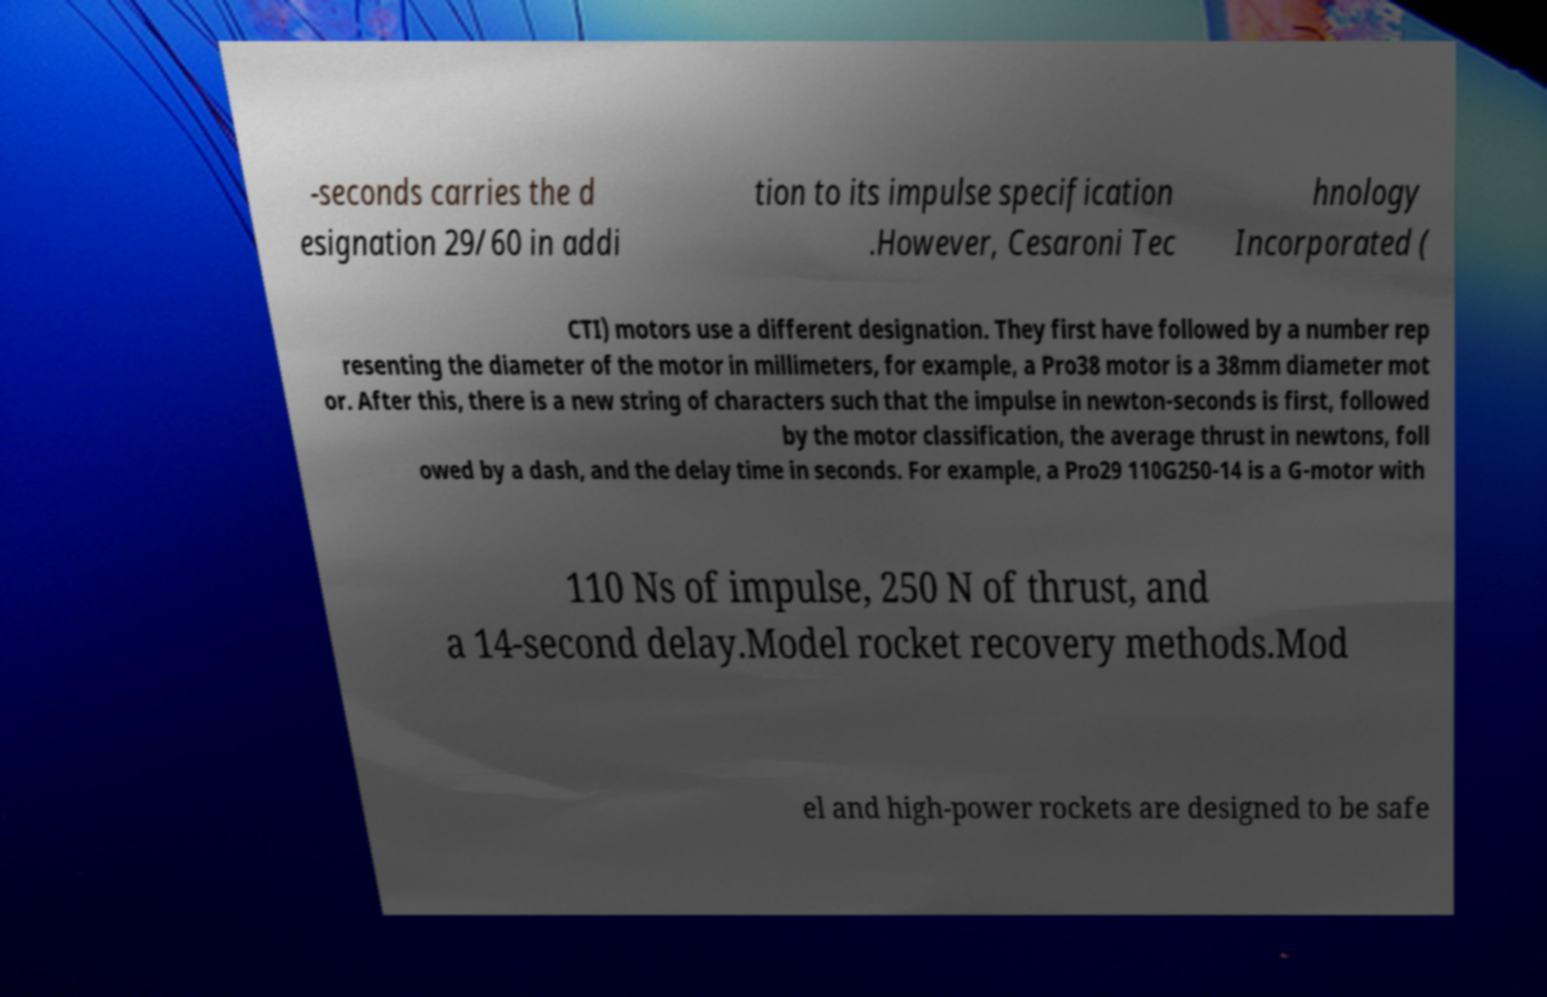Can you read and provide the text displayed in the image?This photo seems to have some interesting text. Can you extract and type it out for me? -seconds carries the d esignation 29/60 in addi tion to its impulse specification .However, Cesaroni Tec hnology Incorporated ( CTI) motors use a different designation. They first have followed by a number rep resenting the diameter of the motor in millimeters, for example, a Pro38 motor is a 38mm diameter mot or. After this, there is a new string of characters such that the impulse in newton-seconds is first, followed by the motor classification, the average thrust in newtons, foll owed by a dash, and the delay time in seconds. For example, a Pro29 110G250-14 is a G-motor with 110 Ns of impulse, 250 N of thrust, and a 14-second delay.Model rocket recovery methods.Mod el and high-power rockets are designed to be safe 